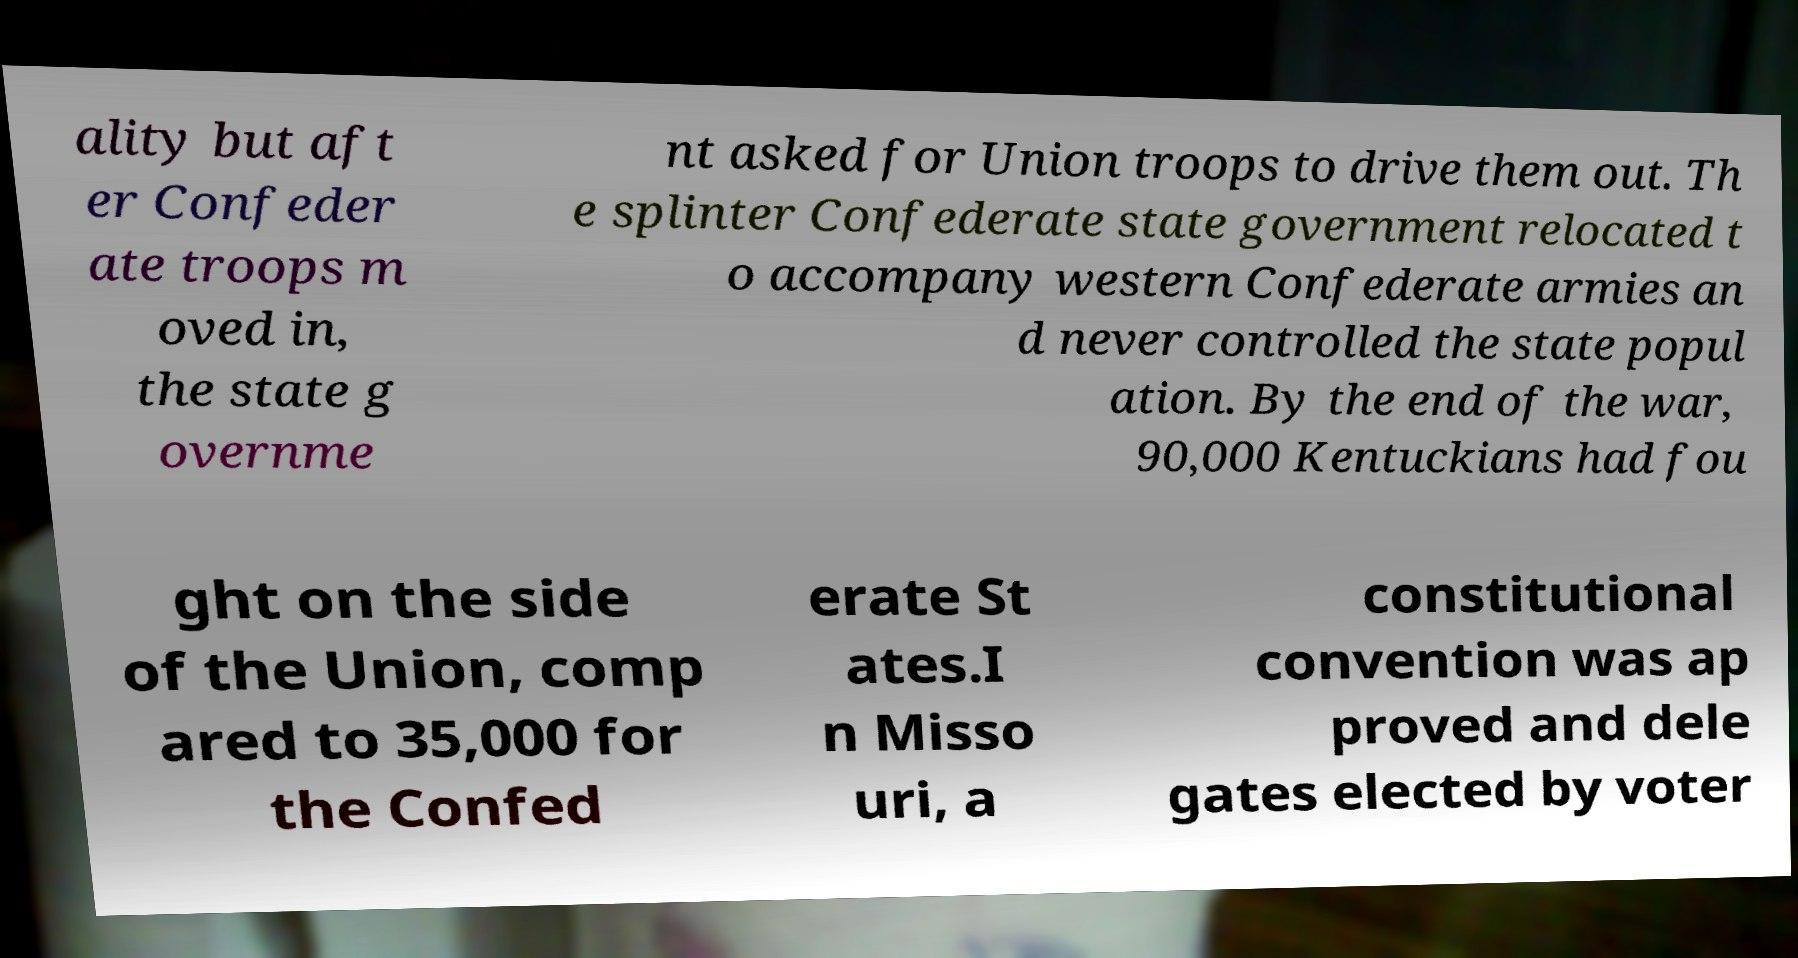I need the written content from this picture converted into text. Can you do that? ality but aft er Confeder ate troops m oved in, the state g overnme nt asked for Union troops to drive them out. Th e splinter Confederate state government relocated t o accompany western Confederate armies an d never controlled the state popul ation. By the end of the war, 90,000 Kentuckians had fou ght on the side of the Union, comp ared to 35,000 for the Confed erate St ates.I n Misso uri, a constitutional convention was ap proved and dele gates elected by voter 